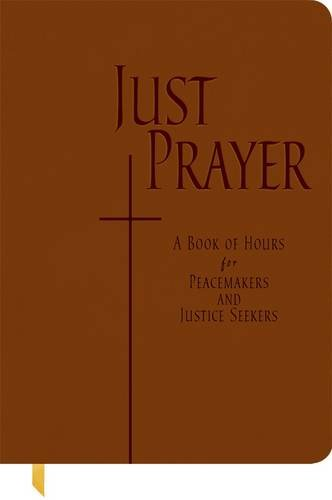What type of book is this? This book falls under the category of Christian Books & Bibles, specializing in offering structured prayer times with a focus on social justice and peacemaking. 